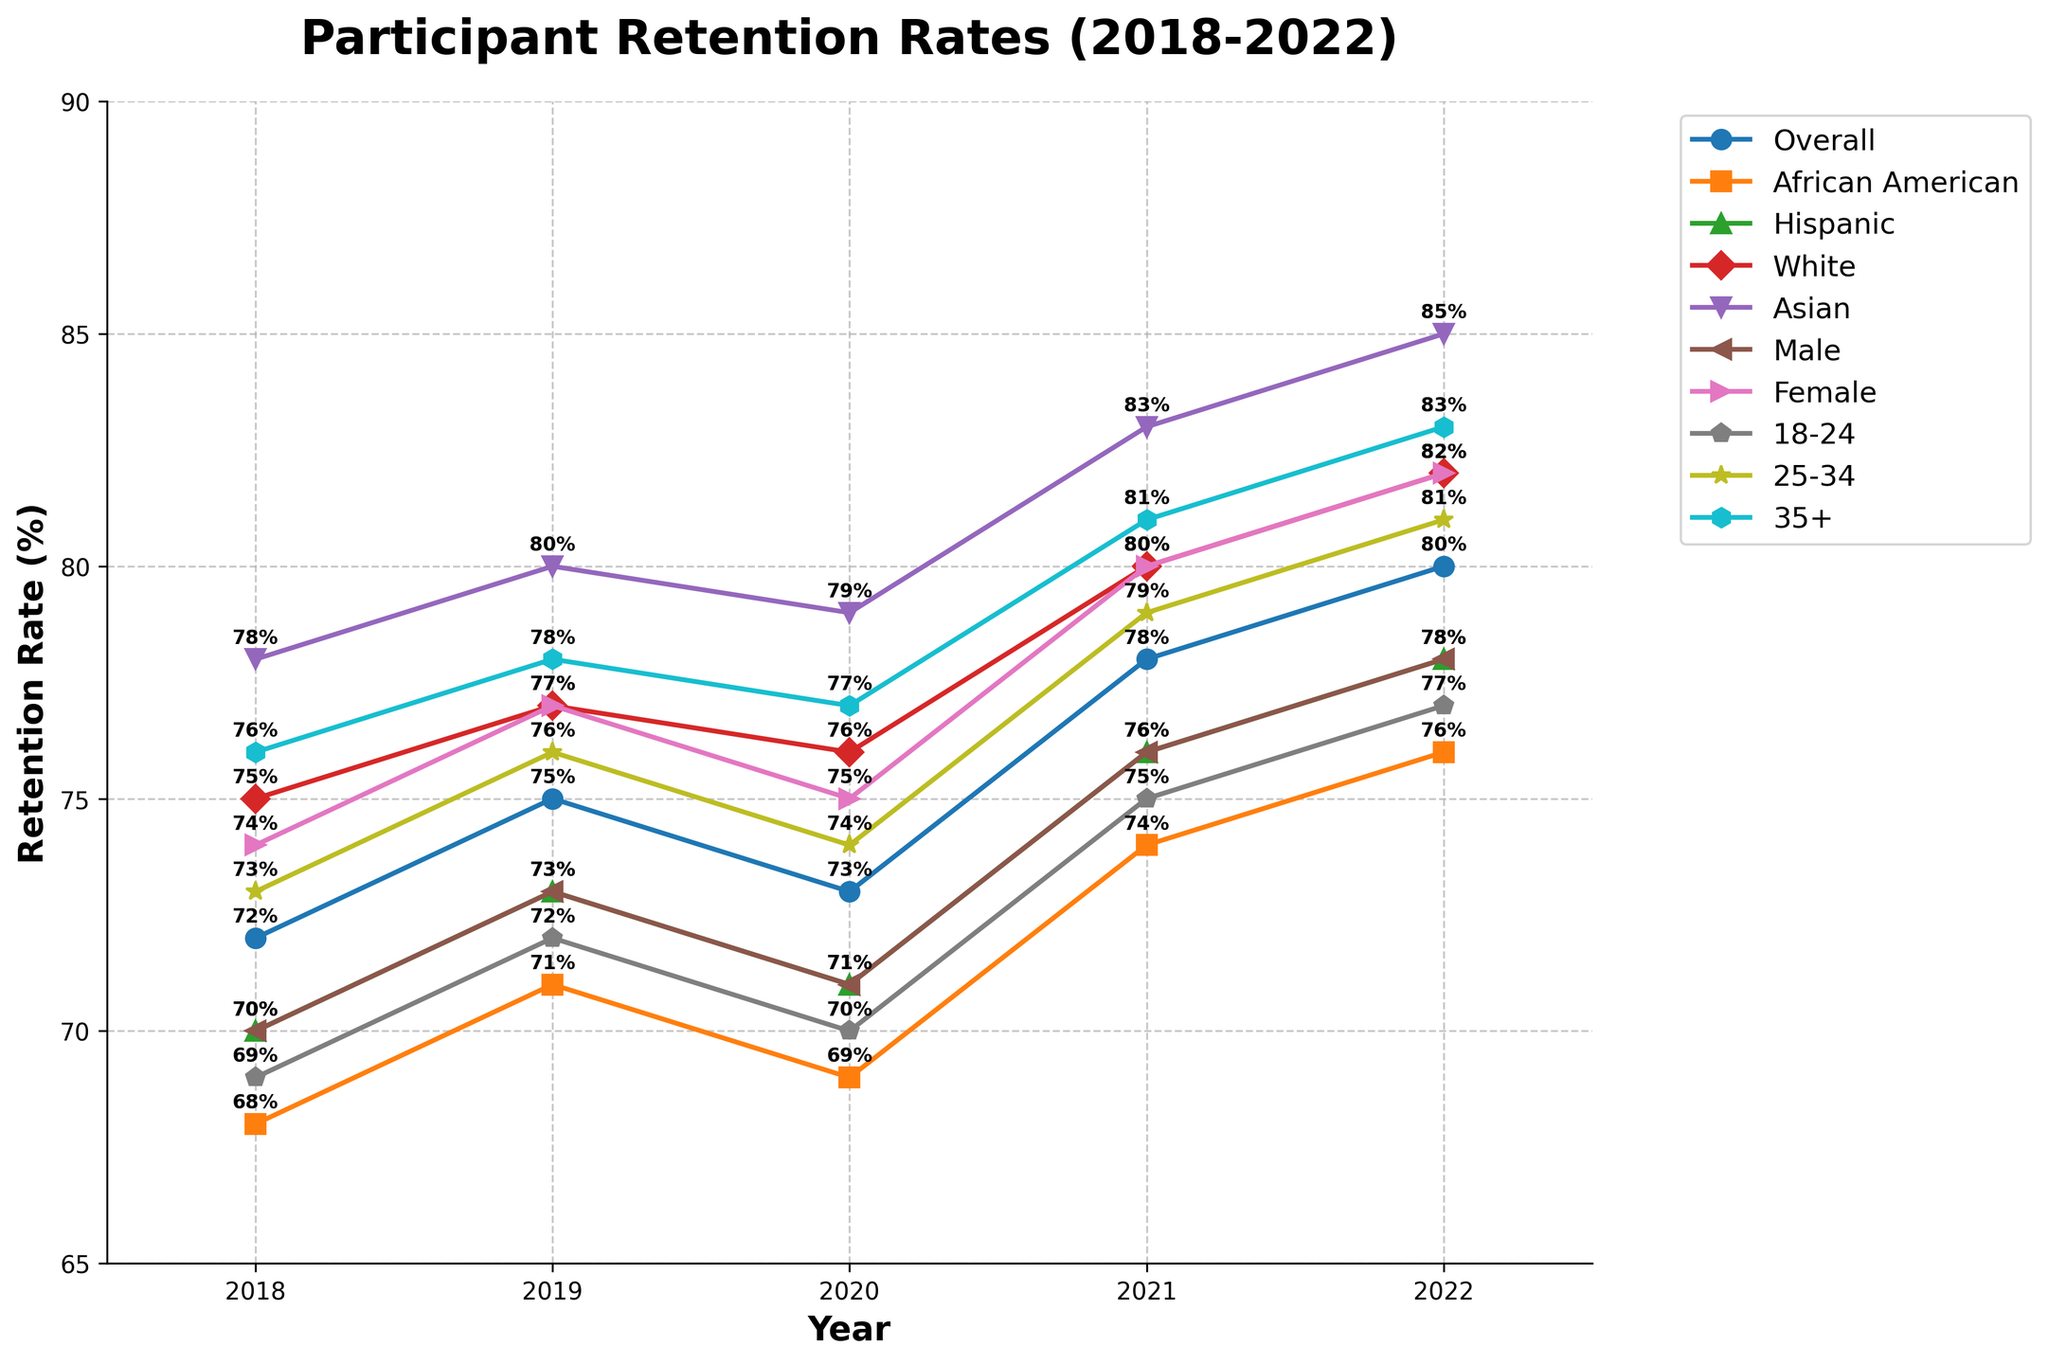What is the overall retention rate trend from 2018 to 2022? The overall retention rate trends upwards from 72% in 2018 to 80% in 2022. By observing the line labeled "Overall," you can see a steady increase over the years.
Answer: Trends upward Which demographic group had the highest retention rate in 2022? The line for the "Asian" demographic is the highest in 2022. Looking at the endpoint for each line, the "Asian" line concludes at 85%.
Answer: Asian How do the retention rates of "Male" and "Female" compare in 2021? In 2021, the "Male" retention rate is 76%, and the "Female" retention rate is 80%. The "Female" retention rate is higher by 4 percentage points.
Answer: Female has a higher retention rate What is the average retention rate for African American participants over the 5 years? The retention rates for African American participants are 68%, 71%, 69%, 74%, and 76%. Sum these (68 + 71 + 69 + 74 + 76 = 358), then divide by 5. 358/5 = 71.6%.
Answer: 71.6% Which age group shows the most improvement in retention rates from 2018 to 2022? The age group "35+" shows the most improvement. It increases from 76% in 2018 to 83% in 2022. By subtracting 76% from 83%, the improvement is found to be 7 percentage points, which is the highest improvement among all age groups.
Answer: 35+ Did Hispanic participants' retention rate ever exceed the overall retention rate in any year? By comparing the Hispanic retention rate to the overall retention rate for each year, we see that in all years, the Hispanic retention rate is slightly below the overall rate. Thus, it never exceeds the overall rate.
Answer: No Which group had the steepest decline in retention rate between any two consecutive years, and when did it happen? The "Overall" group had the steepest decline between 2019 (75%) and 2020 (73%), resulting in a 2 percentage point decrease.
Answer: Overall, 2019 to 2020 What is the difference in retention rates between "White" and "African American" participants in 2022? The retention rate for "White" participants in 2022 is 82%, and for "African American" it is 76%. The difference is 82% - 76% = 6 percentage points.
Answer: 6 percentage points How do the retention rates of participants aged "18-24" and "25-34" compare in 2020? In 2020, the "18-24" age group retention rate is 70%, and the "25-34" group is 74%. The "25-34" age group has a retention rate that is higher by 4 percentage points.
Answer: 25-34 has a higher retention rate What is the retention rate trend for the "Asian" demographic between 2019 and 2021? The retention rate for the "Asian" demographic increases from 80% in 2019 to 79% in 2020 and then to 83% in 2021. There is a slight dip in 2020, but an overall increase over the two years.
Answer: Overall increase with a dip in 2020 